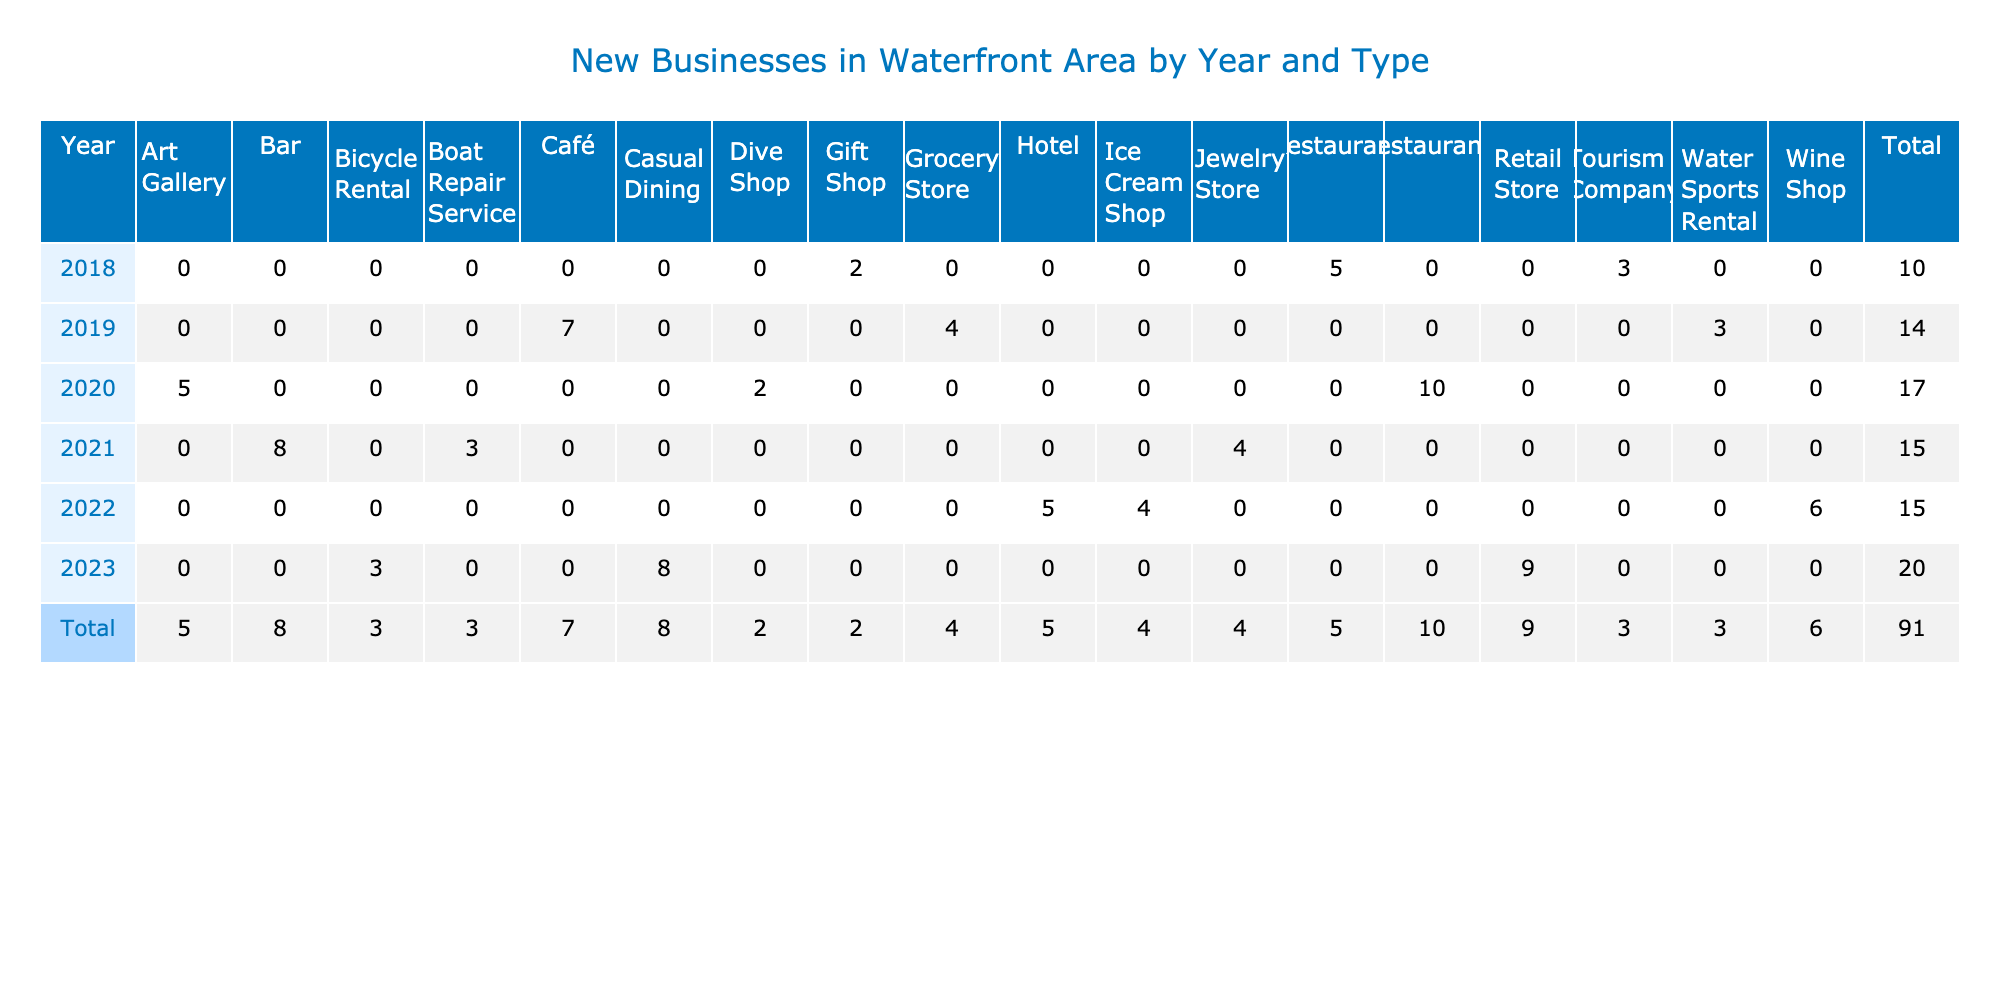What was the total number of new businesses opened in 2020? To find the total for 2020, I look at the row for the year 2020 in the table and sum the number of new businesses opened across all types of businesses listed: 10 (Restaurants) + 5 (Art Gallery) + 2 (Dive Shop) = 17.
Answer: 17 Which type of business opened the most in 2021? In 2021, looking at the number of new businesses by type, I see that the Bar (The Nautical Tap) opened 8 new businesses, which is the highest among all types for that year.
Answer: Bar How many more new businesses were opened in 2023 compared to 2019? From the table, in 2023, the total number of new businesses is 9 (Retail Store) + 8 (Casual Dining) + 3 (Bicycle Rental) = 20. For 2019, the total is 7 (Café) + 4 (Grocery Store) + 3 (Water Sports Rental) = 14. The difference is 20 - 14 = 6.
Answer: 6 Did the number of new restaurants increase from 2019 to 2020? For 2019, there were 7 new eateries (Café) and in 2020, 10 new businesses were opened under the category of Restaurants. Since the number increased from 7 to 10, I conclude that yes, it did increase.
Answer: Yes What is the average number of new businesses opened per year? There are total new businesses from 2018 to 2023 which can be summed up as: 5 + 2 + 3 + 7 + 4 + 3 + 10 + 5 + 2 + 8 + 4 + 3 + 6 + 5 + 4 + 9 + 8 + 3 =  85. Since there are 6 years from 2018 to 2023, the average is 85 / 6 = approximately 14.17.
Answer: 14.17 In which year were the least number of new businesses opened, and how many were there? By checking the totals for each year, I find that 2018 had the least with 10 new businesses (5 Restaurants + 2 Gift Shops + 3 Tourism Companies).
Answer: 2018, 10 How many new hotels were opened in the waterfront area from 2018 to 2023? Looking through the table, I find that only one hotel (Shoreline Inn) was opened in 2022, indicating that there were no new hotels in the other years. Thus, the total number of new hotels is 1.
Answer: 1 Was there any year when more than 10 new businesses were opened? The years 2020 (Total 17, which includes more than 10) had an increase of new businesses opened compared to previous years. Therefore, yes, 2020 is the year with more than 10 new businesses opened.
Answer: Yes Which business type had the highest total openings from 2018 to 2023? Summing the businesses across the years, Restaurants lead with 5 + 10 + 8 = 23, while the next highest is Cafés with 7. So, Restaurants had the highest total openings at 23.
Answer: Restaurants 